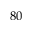<formula> <loc_0><loc_0><loc_500><loc_500>8 0</formula> 